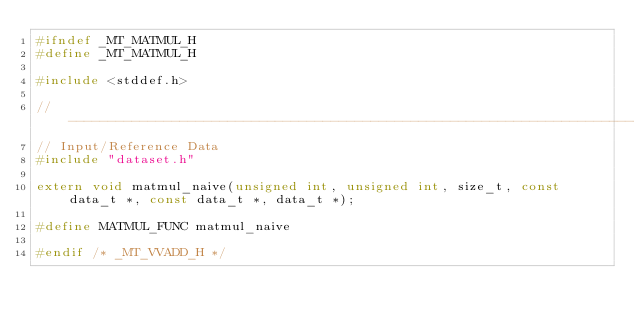Convert code to text. <code><loc_0><loc_0><loc_500><loc_500><_C_>#ifndef _MT_MATMUL_H
#define _MT_MATMUL_H

#include <stddef.h>

//--------------------------------------------------------------------------
// Input/Reference Data
#include "dataset.h"

extern void matmul_naive(unsigned int, unsigned int, size_t, const data_t *, const data_t *, data_t *);

#define MATMUL_FUNC matmul_naive

#endif /* _MT_VVADD_H */
</code> 